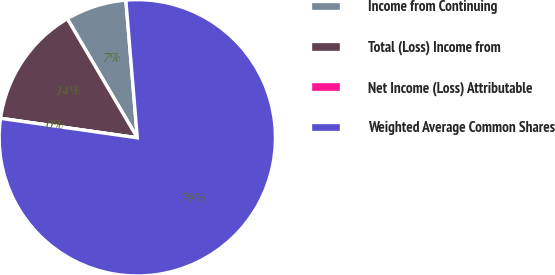Convert chart. <chart><loc_0><loc_0><loc_500><loc_500><pie_chart><fcel>Income from Continuing<fcel>Total (Loss) Income from<fcel>Net Income (Loss) Attributable<fcel>Weighted Average Common Shares<nl><fcel>7.14%<fcel>14.29%<fcel>0.0%<fcel>78.57%<nl></chart> 